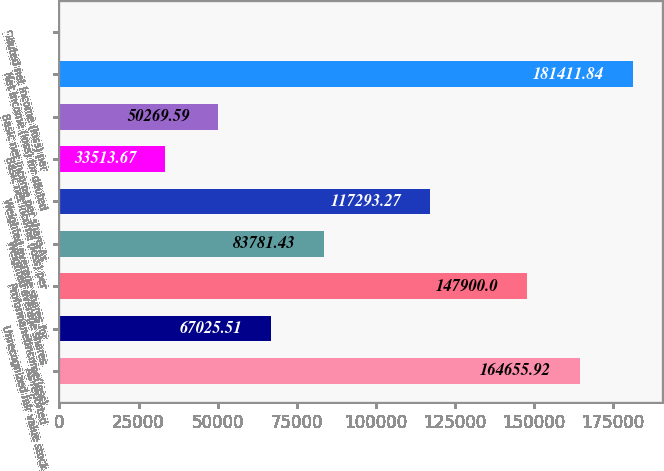<chart> <loc_0><loc_0><loc_500><loc_500><bar_chart><fcel>As reported<fcel>Unrecognized fair value stock<fcel>Proformanetincome(loss)<fcel>Weighted average shares<fcel>Weighted average shares for<fcel>Basic net income (loss) per<fcel>Basic net income per share-As<fcel>Net income (loss) for diluted<fcel>Diluted net income (loss) per<nl><fcel>164656<fcel>67025.5<fcel>147900<fcel>83781.4<fcel>117293<fcel>33513.7<fcel>50269.6<fcel>181412<fcel>1.83<nl></chart> 